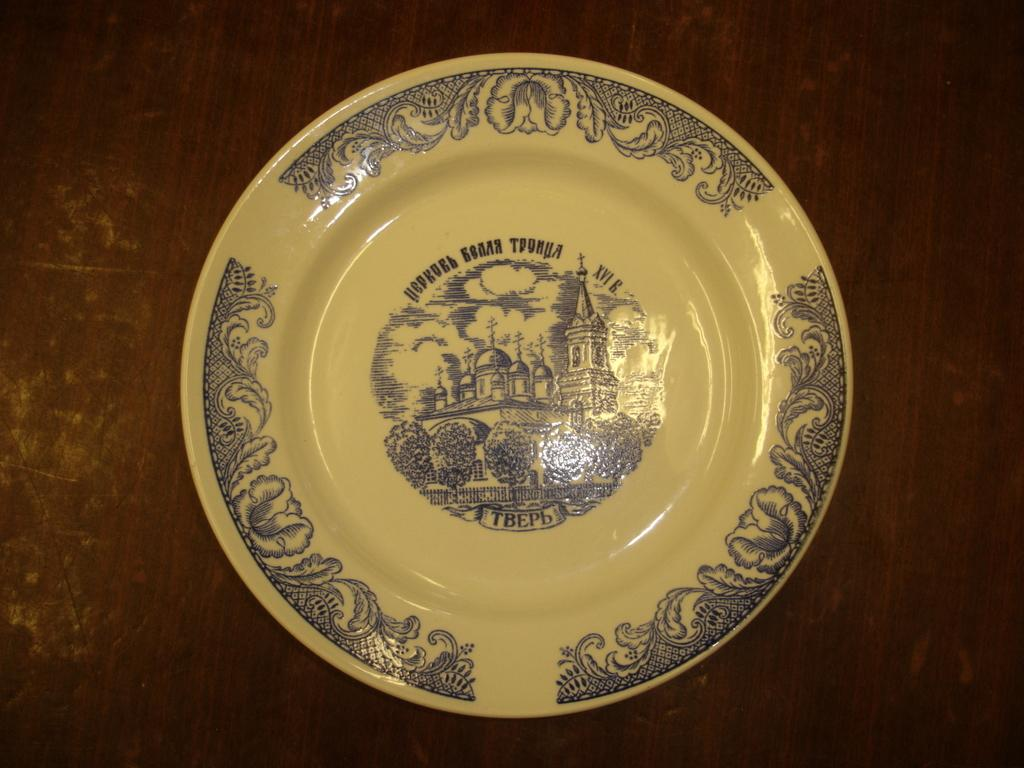What piece of furniture is present in the image? There is a table in the image. What is placed on the table? There is a plate placed on the table. What type of seed is growing on the table in the image? There is no seed or plant growing on the table in the image; it only contains a plate. 